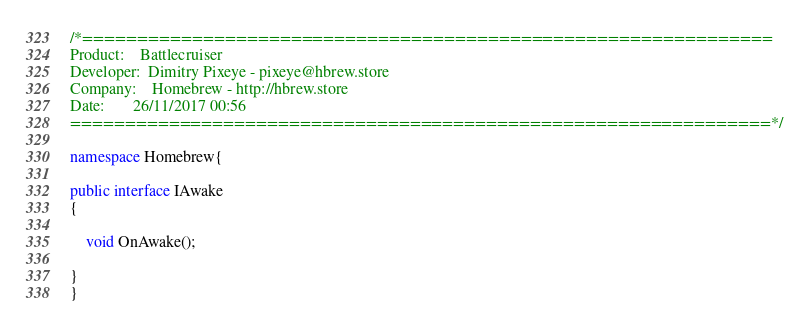<code> <loc_0><loc_0><loc_500><loc_500><_C#_>/*===============================================================
Product:    Battlecruiser
Developer:  Dimitry Pixeye - pixeye@hbrew.store
Company:    Homebrew - http://hbrew.store
Date:       26/11/2017 00:56
================================================================*/

namespace Homebrew{

public interface IAwake
{

    void OnAwake();

}
}</code> 